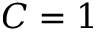<formula> <loc_0><loc_0><loc_500><loc_500>C = 1</formula> 